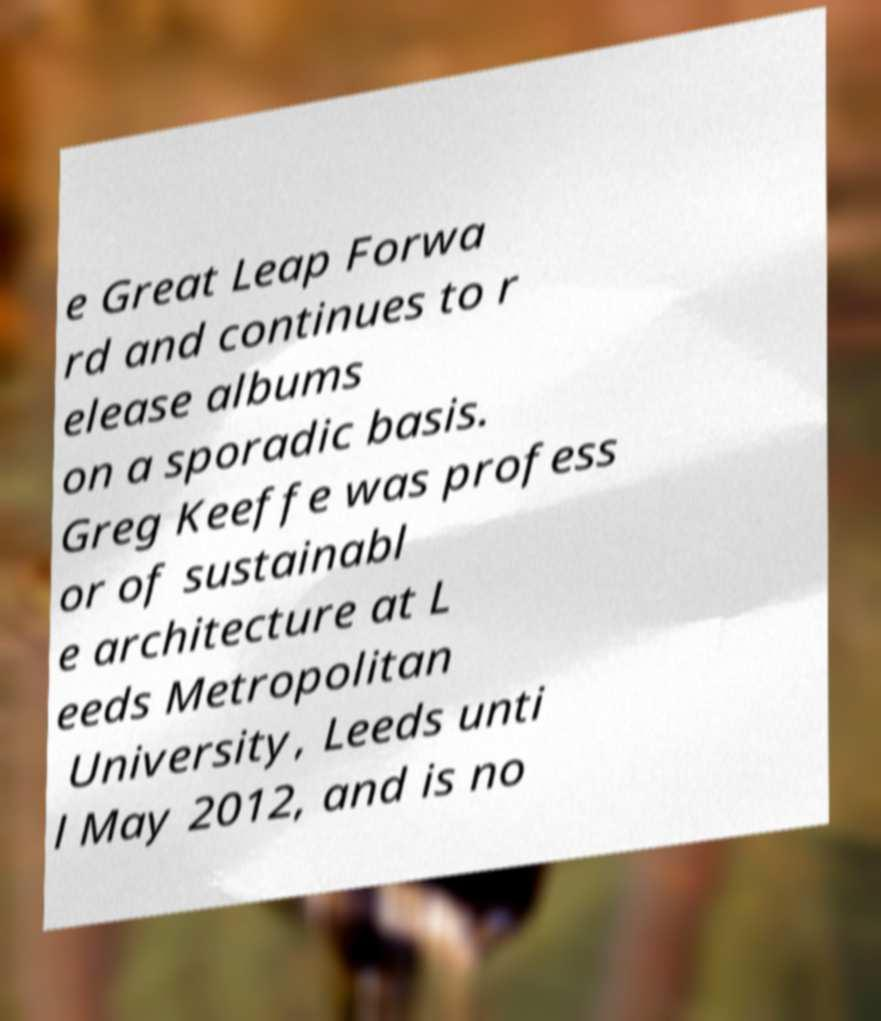Please read and relay the text visible in this image. What does it say? e Great Leap Forwa rd and continues to r elease albums on a sporadic basis. Greg Keeffe was profess or of sustainabl e architecture at L eeds Metropolitan University, Leeds unti l May 2012, and is no 